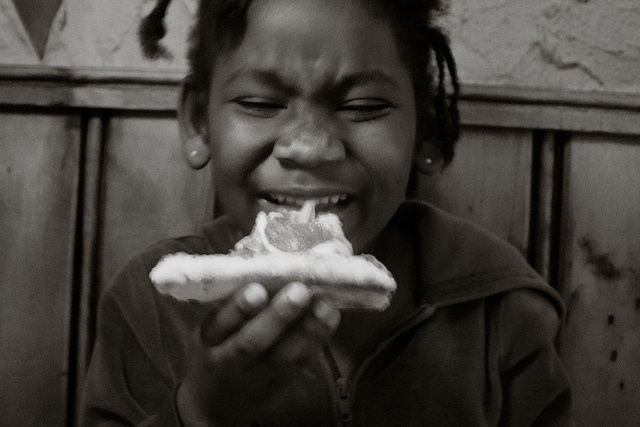Describe the objects in this image and their specific colors. I can see people in gray, black, darkgray, and lightgray tones and pizza in gray, lightgray, darkgray, and black tones in this image. 